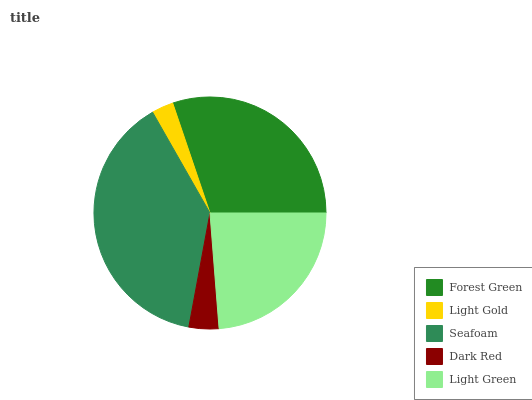Is Light Gold the minimum?
Answer yes or no. Yes. Is Seafoam the maximum?
Answer yes or no. Yes. Is Seafoam the minimum?
Answer yes or no. No. Is Light Gold the maximum?
Answer yes or no. No. Is Seafoam greater than Light Gold?
Answer yes or no. Yes. Is Light Gold less than Seafoam?
Answer yes or no. Yes. Is Light Gold greater than Seafoam?
Answer yes or no. No. Is Seafoam less than Light Gold?
Answer yes or no. No. Is Light Green the high median?
Answer yes or no. Yes. Is Light Green the low median?
Answer yes or no. Yes. Is Dark Red the high median?
Answer yes or no. No. Is Light Gold the low median?
Answer yes or no. No. 